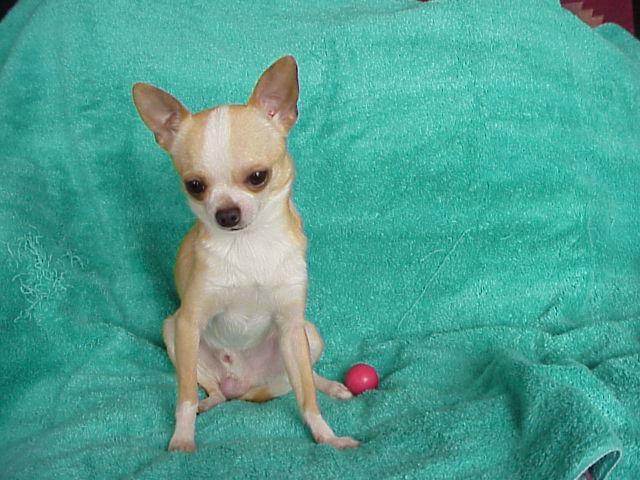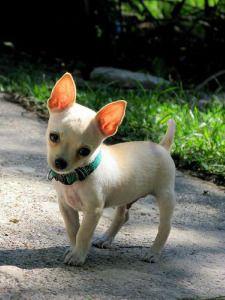The first image is the image on the left, the second image is the image on the right. Analyze the images presented: Is the assertion "At least one of the images features a single dog and shows grass in the image" valid? Answer yes or no. Yes. The first image is the image on the left, the second image is the image on the right. Given the left and right images, does the statement "A leash extends from the small dog in the right-hand image." hold true? Answer yes or no. No. 